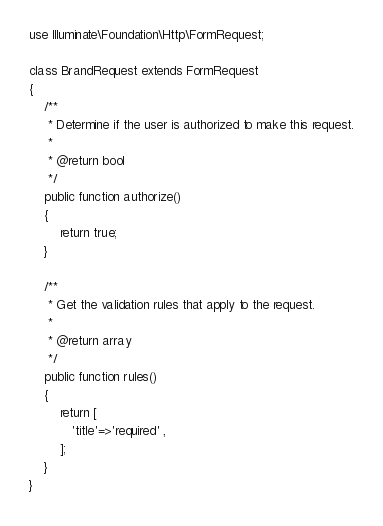<code> <loc_0><loc_0><loc_500><loc_500><_PHP_>
use Illuminate\Foundation\Http\FormRequest;

class BrandRequest extends FormRequest
{
    /**
     * Determine if the user is authorized to make this request.
     *
     * @return bool
     */
    public function authorize()
    {
        return true;
    }

    /**
     * Get the validation rules that apply to the request.
     *
     * @return array
     */
    public function rules()
    {
        return [
           'title'=>'required' ,
        ];
    }
}
</code> 